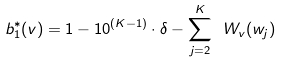<formula> <loc_0><loc_0><loc_500><loc_500>b _ { 1 } ^ { * } ( v ) = 1 - 1 0 ^ { ( K - 1 ) } \cdot \delta - \sum _ { j = 2 } ^ { K } \ W _ { v } ( w _ { j } )</formula> 